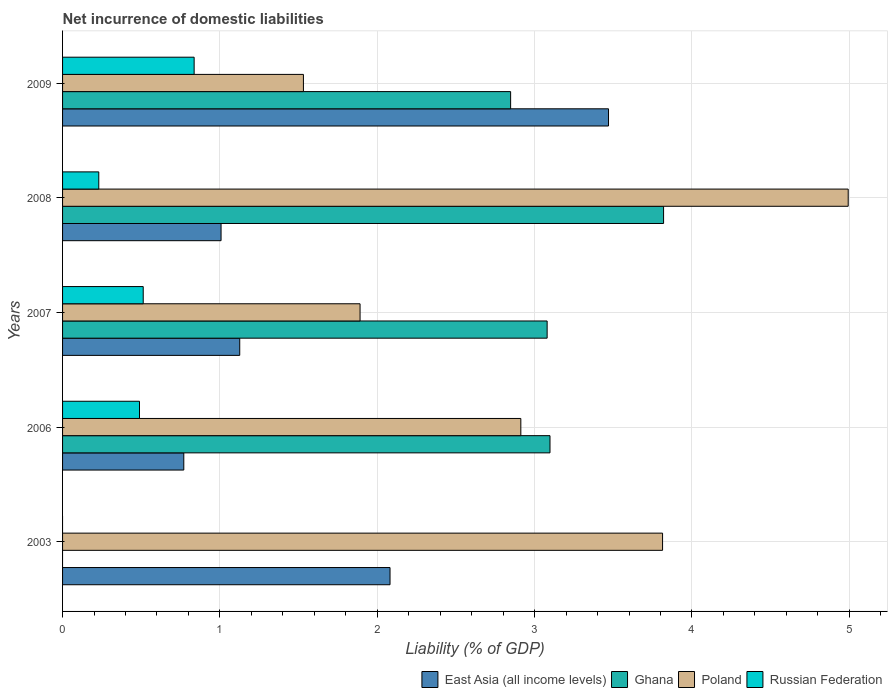How many groups of bars are there?
Your answer should be compact. 5. Are the number of bars on each tick of the Y-axis equal?
Provide a short and direct response. No. How many bars are there on the 2nd tick from the top?
Ensure brevity in your answer.  4. What is the label of the 2nd group of bars from the top?
Keep it short and to the point. 2008. What is the net incurrence of domestic liabilities in East Asia (all income levels) in 2008?
Give a very brief answer. 1.01. Across all years, what is the maximum net incurrence of domestic liabilities in East Asia (all income levels)?
Keep it short and to the point. 3.47. Across all years, what is the minimum net incurrence of domestic liabilities in East Asia (all income levels)?
Offer a terse response. 0.77. What is the total net incurrence of domestic liabilities in Ghana in the graph?
Make the answer very short. 12.84. What is the difference between the net incurrence of domestic liabilities in Poland in 2008 and that in 2009?
Your answer should be very brief. 3.46. What is the difference between the net incurrence of domestic liabilities in East Asia (all income levels) in 2009 and the net incurrence of domestic liabilities in Poland in 2003?
Your answer should be compact. -0.34. What is the average net incurrence of domestic liabilities in East Asia (all income levels) per year?
Keep it short and to the point. 1.69. In the year 2008, what is the difference between the net incurrence of domestic liabilities in East Asia (all income levels) and net incurrence of domestic liabilities in Poland?
Offer a terse response. -3.99. What is the ratio of the net incurrence of domestic liabilities in Ghana in 2007 to that in 2009?
Offer a terse response. 1.08. Is the difference between the net incurrence of domestic liabilities in East Asia (all income levels) in 2006 and 2009 greater than the difference between the net incurrence of domestic liabilities in Poland in 2006 and 2009?
Offer a very short reply. No. What is the difference between the highest and the second highest net incurrence of domestic liabilities in East Asia (all income levels)?
Your answer should be very brief. 1.39. What is the difference between the highest and the lowest net incurrence of domestic liabilities in Russian Federation?
Keep it short and to the point. 0.84. In how many years, is the net incurrence of domestic liabilities in Russian Federation greater than the average net incurrence of domestic liabilities in Russian Federation taken over all years?
Ensure brevity in your answer.  3. Is the sum of the net incurrence of domestic liabilities in Poland in 2007 and 2008 greater than the maximum net incurrence of domestic liabilities in Russian Federation across all years?
Provide a short and direct response. Yes. Is it the case that in every year, the sum of the net incurrence of domestic liabilities in East Asia (all income levels) and net incurrence of domestic liabilities in Poland is greater than the sum of net incurrence of domestic liabilities in Ghana and net incurrence of domestic liabilities in Russian Federation?
Make the answer very short. No. Is it the case that in every year, the sum of the net incurrence of domestic liabilities in Ghana and net incurrence of domestic liabilities in East Asia (all income levels) is greater than the net incurrence of domestic liabilities in Poland?
Make the answer very short. No. How many bars are there?
Ensure brevity in your answer.  18. Are all the bars in the graph horizontal?
Offer a terse response. Yes. How many years are there in the graph?
Keep it short and to the point. 5. How many legend labels are there?
Offer a very short reply. 4. What is the title of the graph?
Your answer should be very brief. Net incurrence of domestic liabilities. Does "Rwanda" appear as one of the legend labels in the graph?
Ensure brevity in your answer.  No. What is the label or title of the X-axis?
Keep it short and to the point. Liability (% of GDP). What is the label or title of the Y-axis?
Ensure brevity in your answer.  Years. What is the Liability (% of GDP) in East Asia (all income levels) in 2003?
Keep it short and to the point. 2.08. What is the Liability (% of GDP) in Ghana in 2003?
Keep it short and to the point. 0. What is the Liability (% of GDP) in Poland in 2003?
Give a very brief answer. 3.81. What is the Liability (% of GDP) in East Asia (all income levels) in 2006?
Keep it short and to the point. 0.77. What is the Liability (% of GDP) of Ghana in 2006?
Your response must be concise. 3.1. What is the Liability (% of GDP) in Poland in 2006?
Offer a terse response. 2.91. What is the Liability (% of GDP) of Russian Federation in 2006?
Ensure brevity in your answer.  0.49. What is the Liability (% of GDP) of East Asia (all income levels) in 2007?
Keep it short and to the point. 1.13. What is the Liability (% of GDP) of Ghana in 2007?
Make the answer very short. 3.08. What is the Liability (% of GDP) of Poland in 2007?
Your answer should be very brief. 1.89. What is the Liability (% of GDP) in Russian Federation in 2007?
Keep it short and to the point. 0.51. What is the Liability (% of GDP) in East Asia (all income levels) in 2008?
Keep it short and to the point. 1.01. What is the Liability (% of GDP) of Ghana in 2008?
Your answer should be compact. 3.82. What is the Liability (% of GDP) of Poland in 2008?
Make the answer very short. 4.99. What is the Liability (% of GDP) of Russian Federation in 2008?
Provide a short and direct response. 0.23. What is the Liability (% of GDP) in East Asia (all income levels) in 2009?
Offer a terse response. 3.47. What is the Liability (% of GDP) of Ghana in 2009?
Provide a short and direct response. 2.85. What is the Liability (% of GDP) of Poland in 2009?
Provide a succinct answer. 1.53. What is the Liability (% of GDP) in Russian Federation in 2009?
Keep it short and to the point. 0.84. Across all years, what is the maximum Liability (% of GDP) in East Asia (all income levels)?
Your answer should be compact. 3.47. Across all years, what is the maximum Liability (% of GDP) of Ghana?
Offer a terse response. 3.82. Across all years, what is the maximum Liability (% of GDP) of Poland?
Ensure brevity in your answer.  4.99. Across all years, what is the maximum Liability (% of GDP) in Russian Federation?
Offer a terse response. 0.84. Across all years, what is the minimum Liability (% of GDP) of East Asia (all income levels)?
Keep it short and to the point. 0.77. Across all years, what is the minimum Liability (% of GDP) of Poland?
Keep it short and to the point. 1.53. What is the total Liability (% of GDP) of East Asia (all income levels) in the graph?
Your response must be concise. 8.45. What is the total Liability (% of GDP) of Ghana in the graph?
Give a very brief answer. 12.84. What is the total Liability (% of GDP) in Poland in the graph?
Your answer should be compact. 15.14. What is the total Liability (% of GDP) of Russian Federation in the graph?
Your answer should be compact. 2.07. What is the difference between the Liability (% of GDP) of East Asia (all income levels) in 2003 and that in 2006?
Your answer should be very brief. 1.31. What is the difference between the Liability (% of GDP) of Poland in 2003 and that in 2006?
Provide a succinct answer. 0.9. What is the difference between the Liability (% of GDP) in East Asia (all income levels) in 2003 and that in 2007?
Offer a terse response. 0.96. What is the difference between the Liability (% of GDP) of Poland in 2003 and that in 2007?
Make the answer very short. 1.92. What is the difference between the Liability (% of GDP) of East Asia (all income levels) in 2003 and that in 2008?
Ensure brevity in your answer.  1.07. What is the difference between the Liability (% of GDP) in Poland in 2003 and that in 2008?
Offer a very short reply. -1.18. What is the difference between the Liability (% of GDP) of East Asia (all income levels) in 2003 and that in 2009?
Ensure brevity in your answer.  -1.39. What is the difference between the Liability (% of GDP) in Poland in 2003 and that in 2009?
Your answer should be very brief. 2.28. What is the difference between the Liability (% of GDP) of East Asia (all income levels) in 2006 and that in 2007?
Keep it short and to the point. -0.36. What is the difference between the Liability (% of GDP) in Ghana in 2006 and that in 2007?
Your response must be concise. 0.02. What is the difference between the Liability (% of GDP) of Poland in 2006 and that in 2007?
Keep it short and to the point. 1.02. What is the difference between the Liability (% of GDP) of Russian Federation in 2006 and that in 2007?
Your answer should be very brief. -0.02. What is the difference between the Liability (% of GDP) of East Asia (all income levels) in 2006 and that in 2008?
Keep it short and to the point. -0.24. What is the difference between the Liability (% of GDP) in Ghana in 2006 and that in 2008?
Make the answer very short. -0.72. What is the difference between the Liability (% of GDP) of Poland in 2006 and that in 2008?
Offer a terse response. -2.08. What is the difference between the Liability (% of GDP) of Russian Federation in 2006 and that in 2008?
Provide a short and direct response. 0.26. What is the difference between the Liability (% of GDP) of East Asia (all income levels) in 2006 and that in 2009?
Keep it short and to the point. -2.7. What is the difference between the Liability (% of GDP) in Ghana in 2006 and that in 2009?
Provide a succinct answer. 0.25. What is the difference between the Liability (% of GDP) of Poland in 2006 and that in 2009?
Offer a terse response. 1.38. What is the difference between the Liability (% of GDP) in Russian Federation in 2006 and that in 2009?
Your answer should be very brief. -0.35. What is the difference between the Liability (% of GDP) in East Asia (all income levels) in 2007 and that in 2008?
Your response must be concise. 0.12. What is the difference between the Liability (% of GDP) of Ghana in 2007 and that in 2008?
Your answer should be compact. -0.74. What is the difference between the Liability (% of GDP) of Poland in 2007 and that in 2008?
Offer a very short reply. -3.1. What is the difference between the Liability (% of GDP) in Russian Federation in 2007 and that in 2008?
Give a very brief answer. 0.28. What is the difference between the Liability (% of GDP) in East Asia (all income levels) in 2007 and that in 2009?
Offer a terse response. -2.34. What is the difference between the Liability (% of GDP) in Ghana in 2007 and that in 2009?
Make the answer very short. 0.23. What is the difference between the Liability (% of GDP) in Poland in 2007 and that in 2009?
Your answer should be very brief. 0.36. What is the difference between the Liability (% of GDP) in Russian Federation in 2007 and that in 2009?
Your answer should be very brief. -0.32. What is the difference between the Liability (% of GDP) in East Asia (all income levels) in 2008 and that in 2009?
Your answer should be compact. -2.46. What is the difference between the Liability (% of GDP) in Ghana in 2008 and that in 2009?
Keep it short and to the point. 0.97. What is the difference between the Liability (% of GDP) in Poland in 2008 and that in 2009?
Keep it short and to the point. 3.46. What is the difference between the Liability (% of GDP) in Russian Federation in 2008 and that in 2009?
Give a very brief answer. -0.61. What is the difference between the Liability (% of GDP) in East Asia (all income levels) in 2003 and the Liability (% of GDP) in Ghana in 2006?
Ensure brevity in your answer.  -1.02. What is the difference between the Liability (% of GDP) in East Asia (all income levels) in 2003 and the Liability (% of GDP) in Poland in 2006?
Ensure brevity in your answer.  -0.83. What is the difference between the Liability (% of GDP) of East Asia (all income levels) in 2003 and the Liability (% of GDP) of Russian Federation in 2006?
Ensure brevity in your answer.  1.59. What is the difference between the Liability (% of GDP) in Poland in 2003 and the Liability (% of GDP) in Russian Federation in 2006?
Make the answer very short. 3.32. What is the difference between the Liability (% of GDP) of East Asia (all income levels) in 2003 and the Liability (% of GDP) of Ghana in 2007?
Keep it short and to the point. -1. What is the difference between the Liability (% of GDP) in East Asia (all income levels) in 2003 and the Liability (% of GDP) in Poland in 2007?
Ensure brevity in your answer.  0.19. What is the difference between the Liability (% of GDP) of East Asia (all income levels) in 2003 and the Liability (% of GDP) of Russian Federation in 2007?
Your response must be concise. 1.57. What is the difference between the Liability (% of GDP) in Poland in 2003 and the Liability (% of GDP) in Russian Federation in 2007?
Keep it short and to the point. 3.3. What is the difference between the Liability (% of GDP) in East Asia (all income levels) in 2003 and the Liability (% of GDP) in Ghana in 2008?
Offer a terse response. -1.74. What is the difference between the Liability (% of GDP) of East Asia (all income levels) in 2003 and the Liability (% of GDP) of Poland in 2008?
Provide a short and direct response. -2.91. What is the difference between the Liability (% of GDP) in East Asia (all income levels) in 2003 and the Liability (% of GDP) in Russian Federation in 2008?
Offer a very short reply. 1.85. What is the difference between the Liability (% of GDP) in Poland in 2003 and the Liability (% of GDP) in Russian Federation in 2008?
Provide a short and direct response. 3.58. What is the difference between the Liability (% of GDP) of East Asia (all income levels) in 2003 and the Liability (% of GDP) of Ghana in 2009?
Keep it short and to the point. -0.77. What is the difference between the Liability (% of GDP) in East Asia (all income levels) in 2003 and the Liability (% of GDP) in Poland in 2009?
Your response must be concise. 0.55. What is the difference between the Liability (% of GDP) in East Asia (all income levels) in 2003 and the Liability (% of GDP) in Russian Federation in 2009?
Ensure brevity in your answer.  1.24. What is the difference between the Liability (% of GDP) in Poland in 2003 and the Liability (% of GDP) in Russian Federation in 2009?
Give a very brief answer. 2.98. What is the difference between the Liability (% of GDP) of East Asia (all income levels) in 2006 and the Liability (% of GDP) of Ghana in 2007?
Offer a terse response. -2.31. What is the difference between the Liability (% of GDP) of East Asia (all income levels) in 2006 and the Liability (% of GDP) of Poland in 2007?
Your response must be concise. -1.12. What is the difference between the Liability (% of GDP) of East Asia (all income levels) in 2006 and the Liability (% of GDP) of Russian Federation in 2007?
Offer a terse response. 0.26. What is the difference between the Liability (% of GDP) in Ghana in 2006 and the Liability (% of GDP) in Poland in 2007?
Provide a short and direct response. 1.21. What is the difference between the Liability (% of GDP) in Ghana in 2006 and the Liability (% of GDP) in Russian Federation in 2007?
Make the answer very short. 2.59. What is the difference between the Liability (% of GDP) in Poland in 2006 and the Liability (% of GDP) in Russian Federation in 2007?
Give a very brief answer. 2.4. What is the difference between the Liability (% of GDP) in East Asia (all income levels) in 2006 and the Liability (% of GDP) in Ghana in 2008?
Your answer should be very brief. -3.05. What is the difference between the Liability (% of GDP) in East Asia (all income levels) in 2006 and the Liability (% of GDP) in Poland in 2008?
Provide a succinct answer. -4.22. What is the difference between the Liability (% of GDP) in East Asia (all income levels) in 2006 and the Liability (% of GDP) in Russian Federation in 2008?
Your response must be concise. 0.54. What is the difference between the Liability (% of GDP) in Ghana in 2006 and the Liability (% of GDP) in Poland in 2008?
Ensure brevity in your answer.  -1.9. What is the difference between the Liability (% of GDP) of Ghana in 2006 and the Liability (% of GDP) of Russian Federation in 2008?
Your answer should be compact. 2.87. What is the difference between the Liability (% of GDP) of Poland in 2006 and the Liability (% of GDP) of Russian Federation in 2008?
Give a very brief answer. 2.68. What is the difference between the Liability (% of GDP) of East Asia (all income levels) in 2006 and the Liability (% of GDP) of Ghana in 2009?
Provide a succinct answer. -2.08. What is the difference between the Liability (% of GDP) in East Asia (all income levels) in 2006 and the Liability (% of GDP) in Poland in 2009?
Ensure brevity in your answer.  -0.76. What is the difference between the Liability (% of GDP) in East Asia (all income levels) in 2006 and the Liability (% of GDP) in Russian Federation in 2009?
Provide a succinct answer. -0.07. What is the difference between the Liability (% of GDP) in Ghana in 2006 and the Liability (% of GDP) in Poland in 2009?
Keep it short and to the point. 1.57. What is the difference between the Liability (% of GDP) of Ghana in 2006 and the Liability (% of GDP) of Russian Federation in 2009?
Offer a very short reply. 2.26. What is the difference between the Liability (% of GDP) of Poland in 2006 and the Liability (% of GDP) of Russian Federation in 2009?
Ensure brevity in your answer.  2.08. What is the difference between the Liability (% of GDP) of East Asia (all income levels) in 2007 and the Liability (% of GDP) of Ghana in 2008?
Offer a terse response. -2.69. What is the difference between the Liability (% of GDP) of East Asia (all income levels) in 2007 and the Liability (% of GDP) of Poland in 2008?
Your response must be concise. -3.87. What is the difference between the Liability (% of GDP) in East Asia (all income levels) in 2007 and the Liability (% of GDP) in Russian Federation in 2008?
Ensure brevity in your answer.  0.9. What is the difference between the Liability (% of GDP) of Ghana in 2007 and the Liability (% of GDP) of Poland in 2008?
Your answer should be compact. -1.91. What is the difference between the Liability (% of GDP) in Ghana in 2007 and the Liability (% of GDP) in Russian Federation in 2008?
Give a very brief answer. 2.85. What is the difference between the Liability (% of GDP) in Poland in 2007 and the Liability (% of GDP) in Russian Federation in 2008?
Keep it short and to the point. 1.66. What is the difference between the Liability (% of GDP) in East Asia (all income levels) in 2007 and the Liability (% of GDP) in Ghana in 2009?
Keep it short and to the point. -1.72. What is the difference between the Liability (% of GDP) in East Asia (all income levels) in 2007 and the Liability (% of GDP) in Poland in 2009?
Offer a very short reply. -0.4. What is the difference between the Liability (% of GDP) of East Asia (all income levels) in 2007 and the Liability (% of GDP) of Russian Federation in 2009?
Provide a short and direct response. 0.29. What is the difference between the Liability (% of GDP) of Ghana in 2007 and the Liability (% of GDP) of Poland in 2009?
Offer a very short reply. 1.55. What is the difference between the Liability (% of GDP) of Ghana in 2007 and the Liability (% of GDP) of Russian Federation in 2009?
Provide a short and direct response. 2.24. What is the difference between the Liability (% of GDP) in Poland in 2007 and the Liability (% of GDP) in Russian Federation in 2009?
Provide a succinct answer. 1.05. What is the difference between the Liability (% of GDP) in East Asia (all income levels) in 2008 and the Liability (% of GDP) in Ghana in 2009?
Offer a terse response. -1.84. What is the difference between the Liability (% of GDP) in East Asia (all income levels) in 2008 and the Liability (% of GDP) in Poland in 2009?
Provide a short and direct response. -0.52. What is the difference between the Liability (% of GDP) of East Asia (all income levels) in 2008 and the Liability (% of GDP) of Russian Federation in 2009?
Ensure brevity in your answer.  0.17. What is the difference between the Liability (% of GDP) of Ghana in 2008 and the Liability (% of GDP) of Poland in 2009?
Your answer should be very brief. 2.29. What is the difference between the Liability (% of GDP) of Ghana in 2008 and the Liability (% of GDP) of Russian Federation in 2009?
Make the answer very short. 2.98. What is the difference between the Liability (% of GDP) in Poland in 2008 and the Liability (% of GDP) in Russian Federation in 2009?
Your answer should be very brief. 4.16. What is the average Liability (% of GDP) of East Asia (all income levels) per year?
Keep it short and to the point. 1.69. What is the average Liability (% of GDP) in Ghana per year?
Ensure brevity in your answer.  2.57. What is the average Liability (% of GDP) in Poland per year?
Your answer should be compact. 3.03. What is the average Liability (% of GDP) of Russian Federation per year?
Provide a succinct answer. 0.41. In the year 2003, what is the difference between the Liability (% of GDP) of East Asia (all income levels) and Liability (% of GDP) of Poland?
Your response must be concise. -1.73. In the year 2006, what is the difference between the Liability (% of GDP) in East Asia (all income levels) and Liability (% of GDP) in Ghana?
Offer a terse response. -2.33. In the year 2006, what is the difference between the Liability (% of GDP) of East Asia (all income levels) and Liability (% of GDP) of Poland?
Make the answer very short. -2.14. In the year 2006, what is the difference between the Liability (% of GDP) of East Asia (all income levels) and Liability (% of GDP) of Russian Federation?
Your response must be concise. 0.28. In the year 2006, what is the difference between the Liability (% of GDP) in Ghana and Liability (% of GDP) in Poland?
Keep it short and to the point. 0.19. In the year 2006, what is the difference between the Liability (% of GDP) of Ghana and Liability (% of GDP) of Russian Federation?
Make the answer very short. 2.61. In the year 2006, what is the difference between the Liability (% of GDP) of Poland and Liability (% of GDP) of Russian Federation?
Provide a succinct answer. 2.42. In the year 2007, what is the difference between the Liability (% of GDP) of East Asia (all income levels) and Liability (% of GDP) of Ghana?
Your answer should be very brief. -1.95. In the year 2007, what is the difference between the Liability (% of GDP) in East Asia (all income levels) and Liability (% of GDP) in Poland?
Make the answer very short. -0.76. In the year 2007, what is the difference between the Liability (% of GDP) in East Asia (all income levels) and Liability (% of GDP) in Russian Federation?
Keep it short and to the point. 0.61. In the year 2007, what is the difference between the Liability (% of GDP) in Ghana and Liability (% of GDP) in Poland?
Your response must be concise. 1.19. In the year 2007, what is the difference between the Liability (% of GDP) of Ghana and Liability (% of GDP) of Russian Federation?
Your answer should be compact. 2.57. In the year 2007, what is the difference between the Liability (% of GDP) in Poland and Liability (% of GDP) in Russian Federation?
Offer a terse response. 1.38. In the year 2008, what is the difference between the Liability (% of GDP) of East Asia (all income levels) and Liability (% of GDP) of Ghana?
Your response must be concise. -2.81. In the year 2008, what is the difference between the Liability (% of GDP) of East Asia (all income levels) and Liability (% of GDP) of Poland?
Give a very brief answer. -3.99. In the year 2008, what is the difference between the Liability (% of GDP) of East Asia (all income levels) and Liability (% of GDP) of Russian Federation?
Your answer should be very brief. 0.78. In the year 2008, what is the difference between the Liability (% of GDP) in Ghana and Liability (% of GDP) in Poland?
Provide a succinct answer. -1.17. In the year 2008, what is the difference between the Liability (% of GDP) in Ghana and Liability (% of GDP) in Russian Federation?
Ensure brevity in your answer.  3.59. In the year 2008, what is the difference between the Liability (% of GDP) of Poland and Liability (% of GDP) of Russian Federation?
Keep it short and to the point. 4.76. In the year 2009, what is the difference between the Liability (% of GDP) of East Asia (all income levels) and Liability (% of GDP) of Ghana?
Give a very brief answer. 0.62. In the year 2009, what is the difference between the Liability (% of GDP) in East Asia (all income levels) and Liability (% of GDP) in Poland?
Provide a succinct answer. 1.94. In the year 2009, what is the difference between the Liability (% of GDP) of East Asia (all income levels) and Liability (% of GDP) of Russian Federation?
Provide a succinct answer. 2.63. In the year 2009, what is the difference between the Liability (% of GDP) of Ghana and Liability (% of GDP) of Poland?
Your response must be concise. 1.32. In the year 2009, what is the difference between the Liability (% of GDP) in Ghana and Liability (% of GDP) in Russian Federation?
Offer a very short reply. 2.01. In the year 2009, what is the difference between the Liability (% of GDP) of Poland and Liability (% of GDP) of Russian Federation?
Your response must be concise. 0.69. What is the ratio of the Liability (% of GDP) in East Asia (all income levels) in 2003 to that in 2006?
Your answer should be very brief. 2.7. What is the ratio of the Liability (% of GDP) of Poland in 2003 to that in 2006?
Your response must be concise. 1.31. What is the ratio of the Liability (% of GDP) in East Asia (all income levels) in 2003 to that in 2007?
Your response must be concise. 1.85. What is the ratio of the Liability (% of GDP) in Poland in 2003 to that in 2007?
Your answer should be very brief. 2.02. What is the ratio of the Liability (% of GDP) of East Asia (all income levels) in 2003 to that in 2008?
Provide a short and direct response. 2.07. What is the ratio of the Liability (% of GDP) of Poland in 2003 to that in 2008?
Ensure brevity in your answer.  0.76. What is the ratio of the Liability (% of GDP) of East Asia (all income levels) in 2003 to that in 2009?
Your answer should be very brief. 0.6. What is the ratio of the Liability (% of GDP) of Poland in 2003 to that in 2009?
Your response must be concise. 2.49. What is the ratio of the Liability (% of GDP) in East Asia (all income levels) in 2006 to that in 2007?
Ensure brevity in your answer.  0.68. What is the ratio of the Liability (% of GDP) in Ghana in 2006 to that in 2007?
Give a very brief answer. 1.01. What is the ratio of the Liability (% of GDP) of Poland in 2006 to that in 2007?
Keep it short and to the point. 1.54. What is the ratio of the Liability (% of GDP) of Russian Federation in 2006 to that in 2007?
Offer a very short reply. 0.95. What is the ratio of the Liability (% of GDP) of East Asia (all income levels) in 2006 to that in 2008?
Your answer should be very brief. 0.77. What is the ratio of the Liability (% of GDP) in Ghana in 2006 to that in 2008?
Provide a short and direct response. 0.81. What is the ratio of the Liability (% of GDP) of Poland in 2006 to that in 2008?
Offer a very short reply. 0.58. What is the ratio of the Liability (% of GDP) in Russian Federation in 2006 to that in 2008?
Offer a terse response. 2.12. What is the ratio of the Liability (% of GDP) of East Asia (all income levels) in 2006 to that in 2009?
Give a very brief answer. 0.22. What is the ratio of the Liability (% of GDP) of Ghana in 2006 to that in 2009?
Your response must be concise. 1.09. What is the ratio of the Liability (% of GDP) of Poland in 2006 to that in 2009?
Your answer should be compact. 1.9. What is the ratio of the Liability (% of GDP) in Russian Federation in 2006 to that in 2009?
Provide a succinct answer. 0.58. What is the ratio of the Liability (% of GDP) of East Asia (all income levels) in 2007 to that in 2008?
Offer a terse response. 1.12. What is the ratio of the Liability (% of GDP) of Ghana in 2007 to that in 2008?
Your answer should be compact. 0.81. What is the ratio of the Liability (% of GDP) of Poland in 2007 to that in 2008?
Make the answer very short. 0.38. What is the ratio of the Liability (% of GDP) of Russian Federation in 2007 to that in 2008?
Make the answer very short. 2.23. What is the ratio of the Liability (% of GDP) in East Asia (all income levels) in 2007 to that in 2009?
Your response must be concise. 0.32. What is the ratio of the Liability (% of GDP) in Ghana in 2007 to that in 2009?
Offer a very short reply. 1.08. What is the ratio of the Liability (% of GDP) in Poland in 2007 to that in 2009?
Your response must be concise. 1.24. What is the ratio of the Liability (% of GDP) of Russian Federation in 2007 to that in 2009?
Keep it short and to the point. 0.61. What is the ratio of the Liability (% of GDP) of East Asia (all income levels) in 2008 to that in 2009?
Offer a very short reply. 0.29. What is the ratio of the Liability (% of GDP) in Ghana in 2008 to that in 2009?
Offer a very short reply. 1.34. What is the ratio of the Liability (% of GDP) of Poland in 2008 to that in 2009?
Offer a very short reply. 3.26. What is the ratio of the Liability (% of GDP) in Russian Federation in 2008 to that in 2009?
Your response must be concise. 0.28. What is the difference between the highest and the second highest Liability (% of GDP) in East Asia (all income levels)?
Provide a succinct answer. 1.39. What is the difference between the highest and the second highest Liability (% of GDP) in Ghana?
Give a very brief answer. 0.72. What is the difference between the highest and the second highest Liability (% of GDP) of Poland?
Your answer should be very brief. 1.18. What is the difference between the highest and the second highest Liability (% of GDP) of Russian Federation?
Make the answer very short. 0.32. What is the difference between the highest and the lowest Liability (% of GDP) in East Asia (all income levels)?
Offer a very short reply. 2.7. What is the difference between the highest and the lowest Liability (% of GDP) of Ghana?
Ensure brevity in your answer.  3.82. What is the difference between the highest and the lowest Liability (% of GDP) in Poland?
Your answer should be very brief. 3.46. What is the difference between the highest and the lowest Liability (% of GDP) of Russian Federation?
Offer a very short reply. 0.84. 